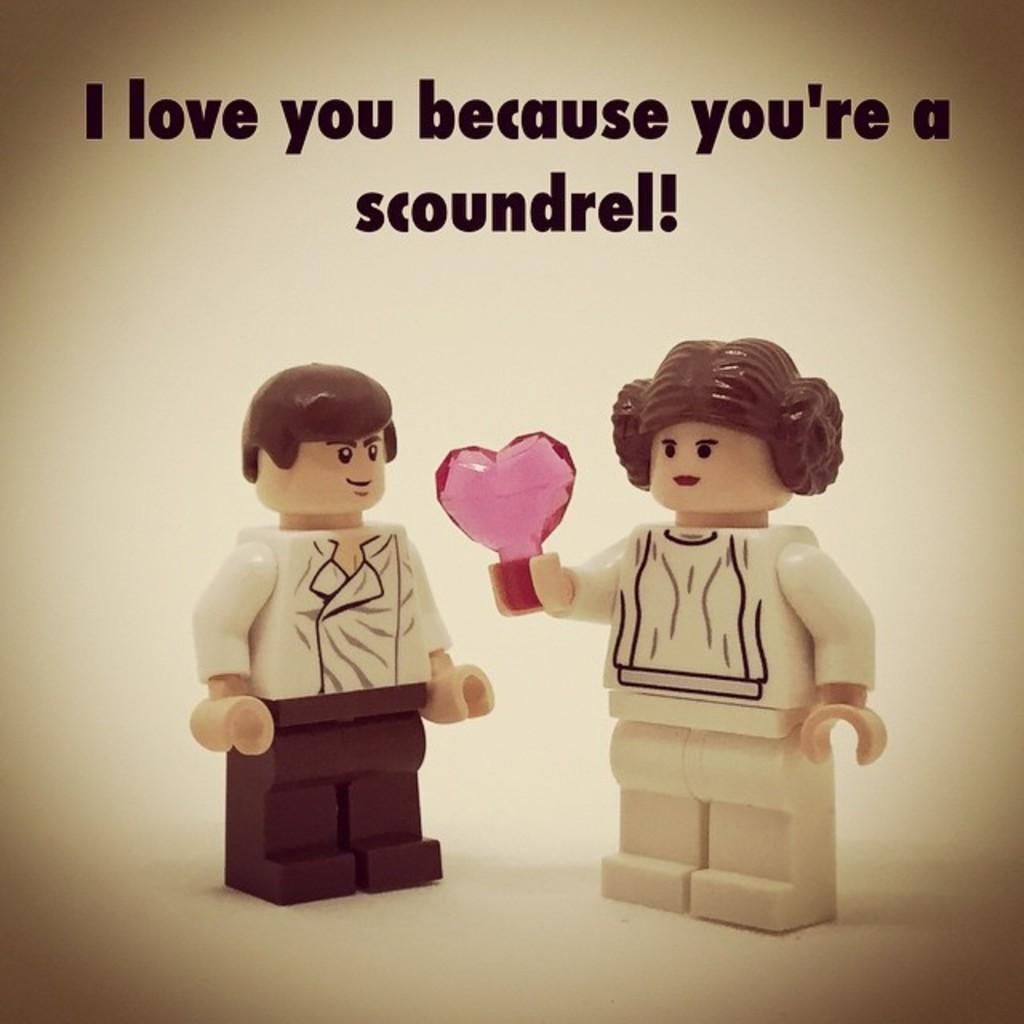Please provide a concise description of this image. In this image, we can see depiction of persons on the yellow background. There is a text at the top of the image. 